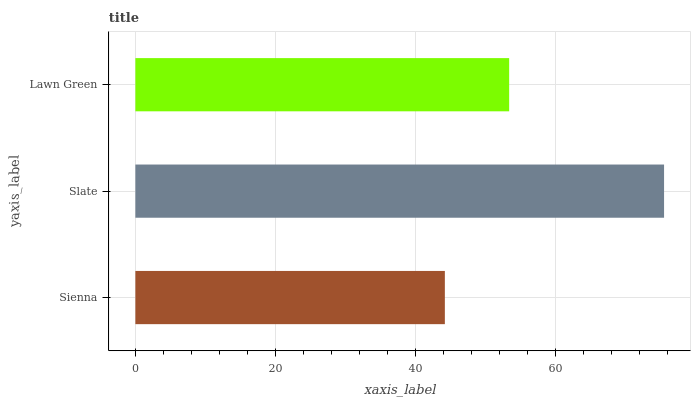Is Sienna the minimum?
Answer yes or no. Yes. Is Slate the maximum?
Answer yes or no. Yes. Is Lawn Green the minimum?
Answer yes or no. No. Is Lawn Green the maximum?
Answer yes or no. No. Is Slate greater than Lawn Green?
Answer yes or no. Yes. Is Lawn Green less than Slate?
Answer yes or no. Yes. Is Lawn Green greater than Slate?
Answer yes or no. No. Is Slate less than Lawn Green?
Answer yes or no. No. Is Lawn Green the high median?
Answer yes or no. Yes. Is Lawn Green the low median?
Answer yes or no. Yes. Is Slate the high median?
Answer yes or no. No. Is Sienna the low median?
Answer yes or no. No. 